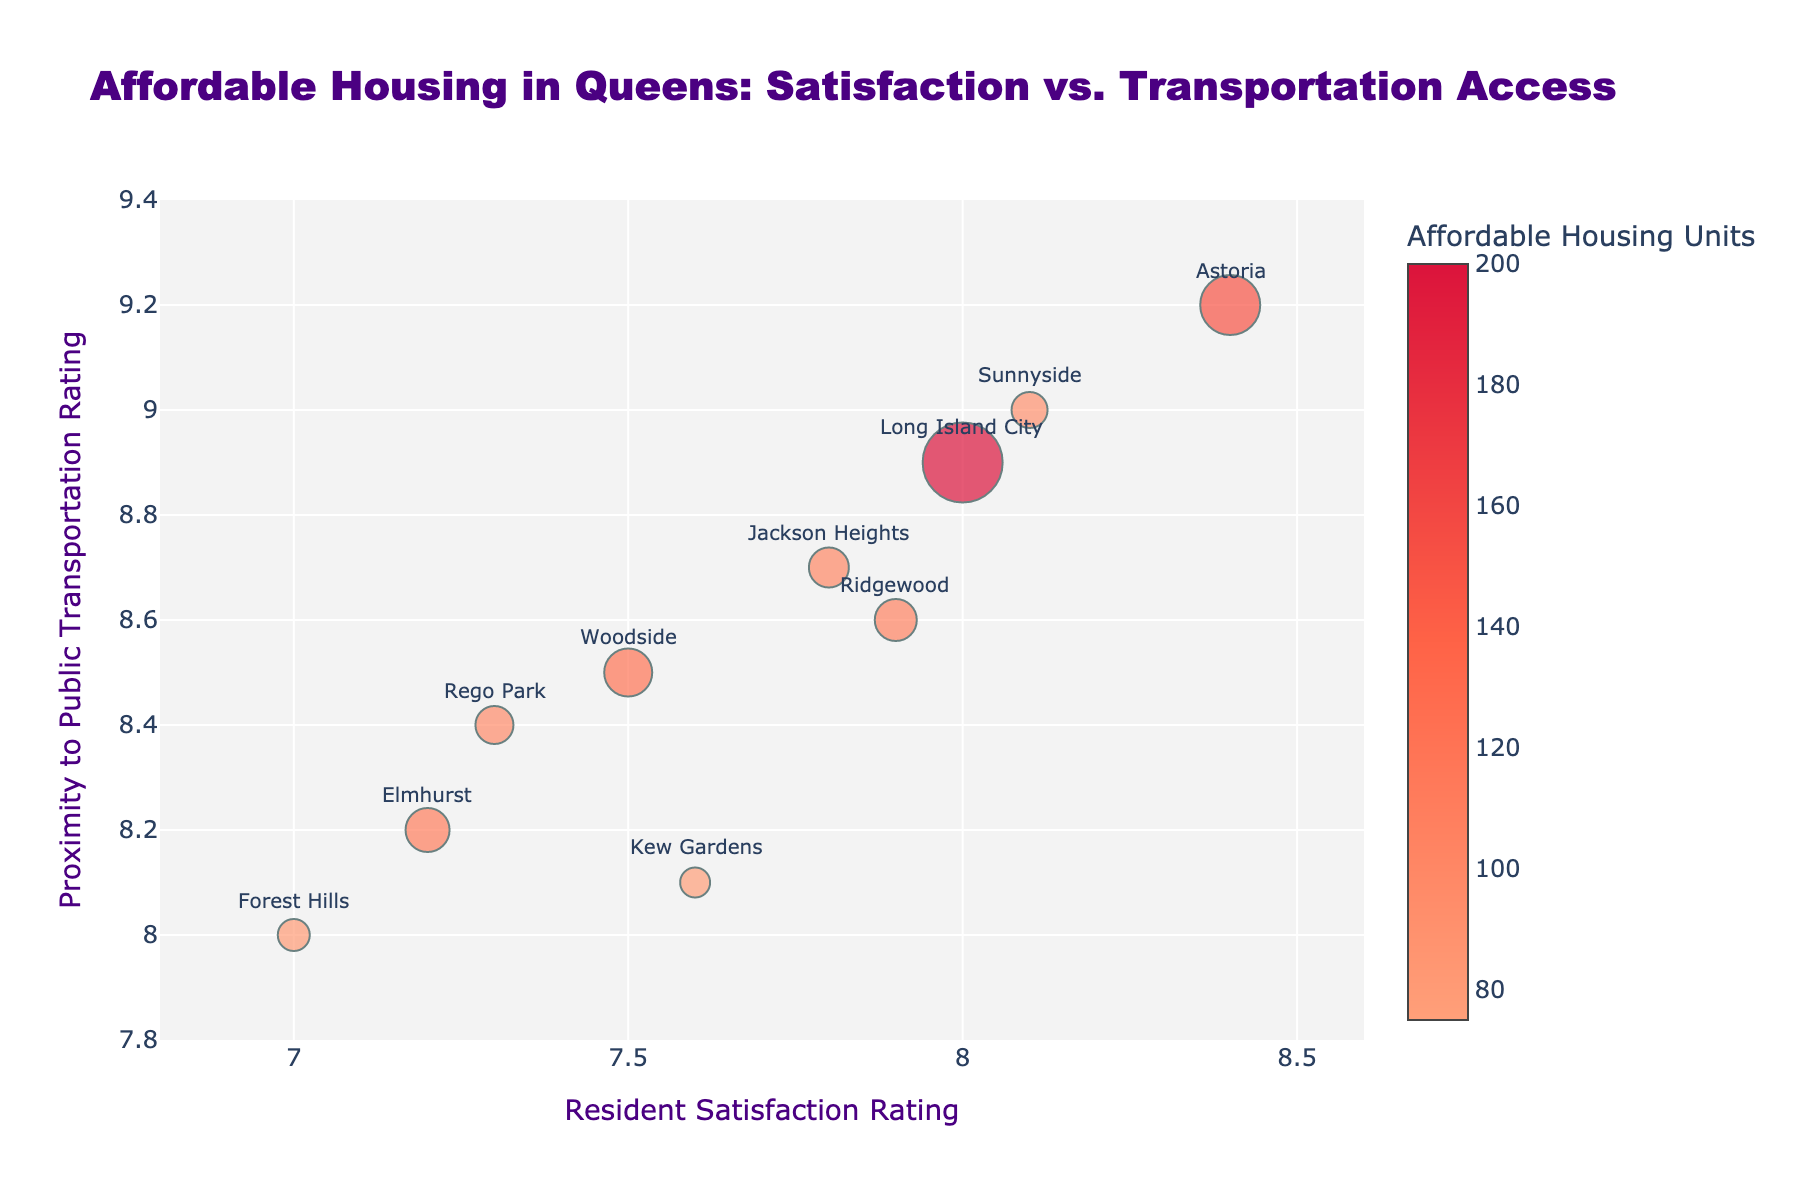What's the title of the figure? The title is usually located at the top of a figure. In this case, it reads: "Affordable Housing in Queens: Satisfaction vs. Transportation Access".
Answer: Affordable Housing in Queens: Satisfaction vs. Transportation Access Which neighborhood has the highest proximity to public transportation rating? Look for the data point corresponding to the highest value on the y-axis. Astoria has the highest proximity to public transportation rating of 9.2.
Answer: Astoria How many affordable housing units are in Long Island City? Identify the marker for Long Island City by hovering or identifying its label, then refer to the color bar or marker size which indicates it has 200 affordable housing units.
Answer: 200 Which neighborhoods have a resident satisfaction rating of 8.0 or higher? Identify the markers higher than or equal to 8.0 on the x-axis. The neighborhoods are Astoria, Long Island City, Sunnyside, and Ridgewood.
Answer: Astoria, Long Island City, Sunnyside, Ridgewood Calculate the average resident satisfaction rating for Elmhurst, Forest Hills, and Rego Park. Add the ratings together and divide by 3: (7.2 + 7.0 + 7.3) / 3 = 21.5 / 3
Answer: 7.17 Which neighborhood has the smallest number of affordable housing units? Look for the smallest marker size. Kew Gardens has the smallest number of affordable housing units at 75.
Answer: Kew Gardens Compare resident satisfaction ratings between Astoria and Jackson Heights. Which is higher? Identify the ratings on the x-axis for both neighborhoods. Astoria has a higher rating of 8.4 compared to Jackson Heights' 7.8.
Answer: Astoria Do any neighborhoods have both a resident satisfaction and a transportation rating below 8.0? Check for markers below 8.0 on both the x and y axes. Forest Hills has both ratings below 8.0 (satisfaction of 7.0 and transportation of 8.0).
Answer: No What is the trend between proximity to public transportation and resident satisfaction ratings across the neighborhoods? Observe the general direction of data points on the plot. As resident satisfaction ratings increase, proximity to public transportation ratings also tend to be higher, indicating a positive correlation.
Answer: Positive correlation Which neighborhood has a resident satisfaction rating of 7.9 and how many affordable housing units does it have? Identify the neighborhood with a rating of 7.9 on the x-axis. Ridgewood has a 7.9 satisfaction rating and 105 affordable housing units.
Answer: Ridgewood has 105 units 